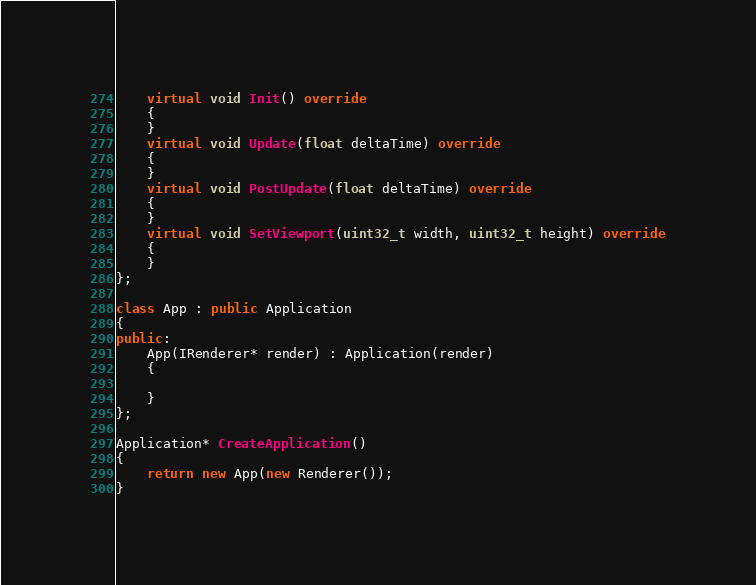Convert code to text. <code><loc_0><loc_0><loc_500><loc_500><_C++_>	virtual void Init() override
	{
	}
	virtual void Update(float deltaTime) override
	{
	}
	virtual void PostUpdate(float deltaTime) override
	{
	}
	virtual void SetViewport(uint32_t width, uint32_t height) override
	{
	}
};

class App : public Application
{
public:
	App(IRenderer* render) : Application(render)
	{

	}
};

Application* CreateApplication()
{
	return new App(new Renderer());
}</code> 